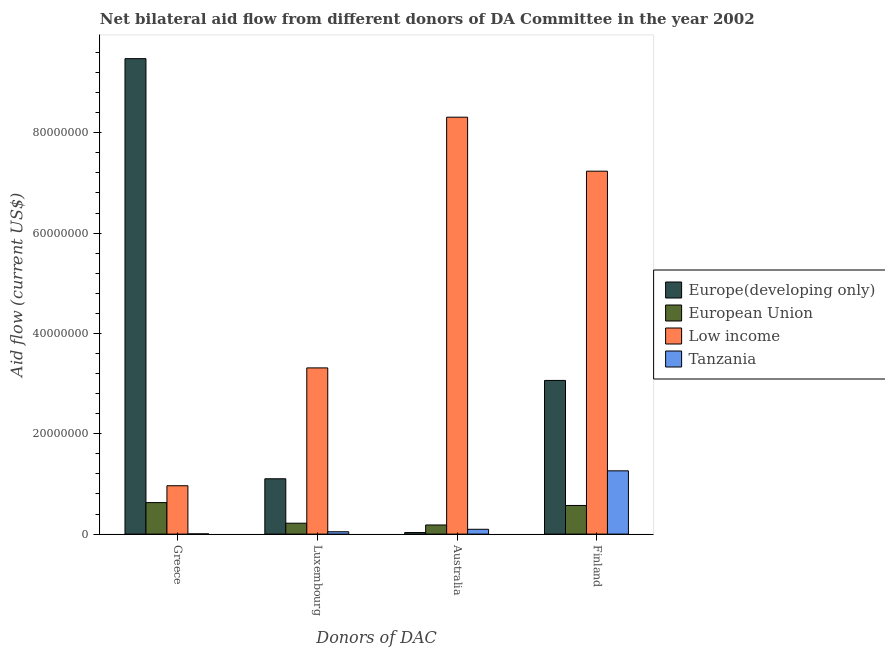How many different coloured bars are there?
Give a very brief answer. 4. Are the number of bars per tick equal to the number of legend labels?
Ensure brevity in your answer.  Yes. How many bars are there on the 1st tick from the left?
Provide a succinct answer. 4. What is the label of the 2nd group of bars from the left?
Keep it short and to the point. Luxembourg. What is the amount of aid given by luxembourg in Europe(developing only)?
Provide a succinct answer. 1.10e+07. Across all countries, what is the maximum amount of aid given by greece?
Provide a succinct answer. 9.48e+07. Across all countries, what is the minimum amount of aid given by luxembourg?
Offer a terse response. 4.70e+05. In which country was the amount of aid given by australia minimum?
Give a very brief answer. Europe(developing only). What is the total amount of aid given by luxembourg in the graph?
Your answer should be compact. 4.68e+07. What is the difference between the amount of aid given by finland in Europe(developing only) and that in European Union?
Ensure brevity in your answer.  2.49e+07. What is the difference between the amount of aid given by greece in Tanzania and the amount of aid given by australia in Low income?
Your answer should be very brief. -8.31e+07. What is the average amount of aid given by luxembourg per country?
Ensure brevity in your answer.  1.17e+07. What is the difference between the amount of aid given by australia and amount of aid given by luxembourg in Low income?
Make the answer very short. 5.00e+07. What is the ratio of the amount of aid given by greece in Tanzania to that in European Union?
Provide a succinct answer. 0.01. Is the amount of aid given by australia in European Union less than that in Low income?
Offer a very short reply. Yes. What is the difference between the highest and the second highest amount of aid given by finland?
Keep it short and to the point. 4.17e+07. What is the difference between the highest and the lowest amount of aid given by australia?
Make the answer very short. 8.28e+07. In how many countries, is the amount of aid given by greece greater than the average amount of aid given by greece taken over all countries?
Your response must be concise. 1. Is the sum of the amount of aid given by luxembourg in European Union and Low income greater than the maximum amount of aid given by australia across all countries?
Provide a short and direct response. No. Is it the case that in every country, the sum of the amount of aid given by australia and amount of aid given by finland is greater than the sum of amount of aid given by luxembourg and amount of aid given by greece?
Offer a very short reply. Yes. What does the 4th bar from the left in Finland represents?
Provide a succinct answer. Tanzania. What does the 4th bar from the right in Finland represents?
Keep it short and to the point. Europe(developing only). Is it the case that in every country, the sum of the amount of aid given by greece and amount of aid given by luxembourg is greater than the amount of aid given by australia?
Give a very brief answer. No. Are the values on the major ticks of Y-axis written in scientific E-notation?
Offer a terse response. No. Does the graph contain any zero values?
Give a very brief answer. No. How are the legend labels stacked?
Offer a terse response. Vertical. What is the title of the graph?
Make the answer very short. Net bilateral aid flow from different donors of DA Committee in the year 2002. Does "Serbia" appear as one of the legend labels in the graph?
Provide a short and direct response. No. What is the label or title of the X-axis?
Ensure brevity in your answer.  Donors of DAC. What is the Aid flow (current US$) in Europe(developing only) in Greece?
Offer a terse response. 9.48e+07. What is the Aid flow (current US$) in European Union in Greece?
Your answer should be compact. 6.28e+06. What is the Aid flow (current US$) in Low income in Greece?
Offer a very short reply. 9.64e+06. What is the Aid flow (current US$) in Tanzania in Greece?
Make the answer very short. 4.00e+04. What is the Aid flow (current US$) of Europe(developing only) in Luxembourg?
Your response must be concise. 1.10e+07. What is the Aid flow (current US$) of European Union in Luxembourg?
Ensure brevity in your answer.  2.17e+06. What is the Aid flow (current US$) of Low income in Luxembourg?
Keep it short and to the point. 3.31e+07. What is the Aid flow (current US$) in Tanzania in Luxembourg?
Keep it short and to the point. 4.70e+05. What is the Aid flow (current US$) of European Union in Australia?
Your answer should be compact. 1.82e+06. What is the Aid flow (current US$) in Low income in Australia?
Your answer should be compact. 8.31e+07. What is the Aid flow (current US$) in Tanzania in Australia?
Your response must be concise. 9.60e+05. What is the Aid flow (current US$) of Europe(developing only) in Finland?
Make the answer very short. 3.06e+07. What is the Aid flow (current US$) in European Union in Finland?
Offer a terse response. 5.71e+06. What is the Aid flow (current US$) in Low income in Finland?
Ensure brevity in your answer.  7.23e+07. What is the Aid flow (current US$) in Tanzania in Finland?
Make the answer very short. 1.26e+07. Across all Donors of DAC, what is the maximum Aid flow (current US$) in Europe(developing only)?
Ensure brevity in your answer.  9.48e+07. Across all Donors of DAC, what is the maximum Aid flow (current US$) of European Union?
Provide a short and direct response. 6.28e+06. Across all Donors of DAC, what is the maximum Aid flow (current US$) in Low income?
Provide a short and direct response. 8.31e+07. Across all Donors of DAC, what is the maximum Aid flow (current US$) of Tanzania?
Keep it short and to the point. 1.26e+07. Across all Donors of DAC, what is the minimum Aid flow (current US$) of Europe(developing only)?
Make the answer very short. 3.10e+05. Across all Donors of DAC, what is the minimum Aid flow (current US$) in European Union?
Provide a short and direct response. 1.82e+06. Across all Donors of DAC, what is the minimum Aid flow (current US$) in Low income?
Keep it short and to the point. 9.64e+06. Across all Donors of DAC, what is the minimum Aid flow (current US$) of Tanzania?
Give a very brief answer. 4.00e+04. What is the total Aid flow (current US$) of Europe(developing only) in the graph?
Provide a succinct answer. 1.37e+08. What is the total Aid flow (current US$) of European Union in the graph?
Make the answer very short. 1.60e+07. What is the total Aid flow (current US$) of Low income in the graph?
Offer a terse response. 1.98e+08. What is the total Aid flow (current US$) of Tanzania in the graph?
Ensure brevity in your answer.  1.41e+07. What is the difference between the Aid flow (current US$) of Europe(developing only) in Greece and that in Luxembourg?
Give a very brief answer. 8.37e+07. What is the difference between the Aid flow (current US$) of European Union in Greece and that in Luxembourg?
Your answer should be very brief. 4.11e+06. What is the difference between the Aid flow (current US$) in Low income in Greece and that in Luxembourg?
Your response must be concise. -2.35e+07. What is the difference between the Aid flow (current US$) of Tanzania in Greece and that in Luxembourg?
Provide a succinct answer. -4.30e+05. What is the difference between the Aid flow (current US$) in Europe(developing only) in Greece and that in Australia?
Keep it short and to the point. 9.45e+07. What is the difference between the Aid flow (current US$) in European Union in Greece and that in Australia?
Keep it short and to the point. 4.46e+06. What is the difference between the Aid flow (current US$) of Low income in Greece and that in Australia?
Offer a terse response. -7.35e+07. What is the difference between the Aid flow (current US$) in Tanzania in Greece and that in Australia?
Provide a succinct answer. -9.20e+05. What is the difference between the Aid flow (current US$) in Europe(developing only) in Greece and that in Finland?
Make the answer very short. 6.41e+07. What is the difference between the Aid flow (current US$) of European Union in Greece and that in Finland?
Give a very brief answer. 5.70e+05. What is the difference between the Aid flow (current US$) in Low income in Greece and that in Finland?
Offer a very short reply. -6.27e+07. What is the difference between the Aid flow (current US$) of Tanzania in Greece and that in Finland?
Your answer should be very brief. -1.26e+07. What is the difference between the Aid flow (current US$) in Europe(developing only) in Luxembourg and that in Australia?
Offer a terse response. 1.07e+07. What is the difference between the Aid flow (current US$) in European Union in Luxembourg and that in Australia?
Make the answer very short. 3.50e+05. What is the difference between the Aid flow (current US$) of Low income in Luxembourg and that in Australia?
Provide a succinct answer. -5.00e+07. What is the difference between the Aid flow (current US$) of Tanzania in Luxembourg and that in Australia?
Offer a terse response. -4.90e+05. What is the difference between the Aid flow (current US$) in Europe(developing only) in Luxembourg and that in Finland?
Keep it short and to the point. -1.96e+07. What is the difference between the Aid flow (current US$) of European Union in Luxembourg and that in Finland?
Make the answer very short. -3.54e+06. What is the difference between the Aid flow (current US$) of Low income in Luxembourg and that in Finland?
Provide a short and direct response. -3.92e+07. What is the difference between the Aid flow (current US$) in Tanzania in Luxembourg and that in Finland?
Offer a very short reply. -1.21e+07. What is the difference between the Aid flow (current US$) in Europe(developing only) in Australia and that in Finland?
Make the answer very short. -3.03e+07. What is the difference between the Aid flow (current US$) of European Union in Australia and that in Finland?
Your answer should be very brief. -3.89e+06. What is the difference between the Aid flow (current US$) in Low income in Australia and that in Finland?
Your answer should be compact. 1.08e+07. What is the difference between the Aid flow (current US$) in Tanzania in Australia and that in Finland?
Offer a terse response. -1.16e+07. What is the difference between the Aid flow (current US$) in Europe(developing only) in Greece and the Aid flow (current US$) in European Union in Luxembourg?
Offer a very short reply. 9.26e+07. What is the difference between the Aid flow (current US$) of Europe(developing only) in Greece and the Aid flow (current US$) of Low income in Luxembourg?
Make the answer very short. 6.16e+07. What is the difference between the Aid flow (current US$) of Europe(developing only) in Greece and the Aid flow (current US$) of Tanzania in Luxembourg?
Keep it short and to the point. 9.43e+07. What is the difference between the Aid flow (current US$) in European Union in Greece and the Aid flow (current US$) in Low income in Luxembourg?
Provide a short and direct response. -2.68e+07. What is the difference between the Aid flow (current US$) of European Union in Greece and the Aid flow (current US$) of Tanzania in Luxembourg?
Ensure brevity in your answer.  5.81e+06. What is the difference between the Aid flow (current US$) of Low income in Greece and the Aid flow (current US$) of Tanzania in Luxembourg?
Provide a short and direct response. 9.17e+06. What is the difference between the Aid flow (current US$) of Europe(developing only) in Greece and the Aid flow (current US$) of European Union in Australia?
Give a very brief answer. 9.30e+07. What is the difference between the Aid flow (current US$) in Europe(developing only) in Greece and the Aid flow (current US$) in Low income in Australia?
Your answer should be very brief. 1.17e+07. What is the difference between the Aid flow (current US$) in Europe(developing only) in Greece and the Aid flow (current US$) in Tanzania in Australia?
Offer a terse response. 9.38e+07. What is the difference between the Aid flow (current US$) of European Union in Greece and the Aid flow (current US$) of Low income in Australia?
Your answer should be very brief. -7.68e+07. What is the difference between the Aid flow (current US$) of European Union in Greece and the Aid flow (current US$) of Tanzania in Australia?
Keep it short and to the point. 5.32e+06. What is the difference between the Aid flow (current US$) in Low income in Greece and the Aid flow (current US$) in Tanzania in Australia?
Your answer should be compact. 8.68e+06. What is the difference between the Aid flow (current US$) in Europe(developing only) in Greece and the Aid flow (current US$) in European Union in Finland?
Make the answer very short. 8.91e+07. What is the difference between the Aid flow (current US$) in Europe(developing only) in Greece and the Aid flow (current US$) in Low income in Finland?
Your answer should be very brief. 2.24e+07. What is the difference between the Aid flow (current US$) in Europe(developing only) in Greece and the Aid flow (current US$) in Tanzania in Finland?
Provide a succinct answer. 8.22e+07. What is the difference between the Aid flow (current US$) in European Union in Greece and the Aid flow (current US$) in Low income in Finland?
Offer a terse response. -6.61e+07. What is the difference between the Aid flow (current US$) of European Union in Greece and the Aid flow (current US$) of Tanzania in Finland?
Provide a succinct answer. -6.33e+06. What is the difference between the Aid flow (current US$) in Low income in Greece and the Aid flow (current US$) in Tanzania in Finland?
Your response must be concise. -2.97e+06. What is the difference between the Aid flow (current US$) of Europe(developing only) in Luxembourg and the Aid flow (current US$) of European Union in Australia?
Provide a succinct answer. 9.21e+06. What is the difference between the Aid flow (current US$) in Europe(developing only) in Luxembourg and the Aid flow (current US$) in Low income in Australia?
Offer a terse response. -7.21e+07. What is the difference between the Aid flow (current US$) of Europe(developing only) in Luxembourg and the Aid flow (current US$) of Tanzania in Australia?
Offer a very short reply. 1.01e+07. What is the difference between the Aid flow (current US$) of European Union in Luxembourg and the Aid flow (current US$) of Low income in Australia?
Offer a terse response. -8.09e+07. What is the difference between the Aid flow (current US$) in European Union in Luxembourg and the Aid flow (current US$) in Tanzania in Australia?
Your response must be concise. 1.21e+06. What is the difference between the Aid flow (current US$) of Low income in Luxembourg and the Aid flow (current US$) of Tanzania in Australia?
Keep it short and to the point. 3.22e+07. What is the difference between the Aid flow (current US$) of Europe(developing only) in Luxembourg and the Aid flow (current US$) of European Union in Finland?
Your answer should be compact. 5.32e+06. What is the difference between the Aid flow (current US$) in Europe(developing only) in Luxembourg and the Aid flow (current US$) in Low income in Finland?
Give a very brief answer. -6.13e+07. What is the difference between the Aid flow (current US$) in Europe(developing only) in Luxembourg and the Aid flow (current US$) in Tanzania in Finland?
Offer a very short reply. -1.58e+06. What is the difference between the Aid flow (current US$) of European Union in Luxembourg and the Aid flow (current US$) of Low income in Finland?
Provide a short and direct response. -7.02e+07. What is the difference between the Aid flow (current US$) of European Union in Luxembourg and the Aid flow (current US$) of Tanzania in Finland?
Give a very brief answer. -1.04e+07. What is the difference between the Aid flow (current US$) in Low income in Luxembourg and the Aid flow (current US$) in Tanzania in Finland?
Provide a short and direct response. 2.05e+07. What is the difference between the Aid flow (current US$) in Europe(developing only) in Australia and the Aid flow (current US$) in European Union in Finland?
Your answer should be very brief. -5.40e+06. What is the difference between the Aid flow (current US$) in Europe(developing only) in Australia and the Aid flow (current US$) in Low income in Finland?
Give a very brief answer. -7.20e+07. What is the difference between the Aid flow (current US$) in Europe(developing only) in Australia and the Aid flow (current US$) in Tanzania in Finland?
Your response must be concise. -1.23e+07. What is the difference between the Aid flow (current US$) of European Union in Australia and the Aid flow (current US$) of Low income in Finland?
Make the answer very short. -7.05e+07. What is the difference between the Aid flow (current US$) of European Union in Australia and the Aid flow (current US$) of Tanzania in Finland?
Ensure brevity in your answer.  -1.08e+07. What is the difference between the Aid flow (current US$) of Low income in Australia and the Aid flow (current US$) of Tanzania in Finland?
Make the answer very short. 7.05e+07. What is the average Aid flow (current US$) in Europe(developing only) per Donors of DAC?
Offer a terse response. 3.42e+07. What is the average Aid flow (current US$) of European Union per Donors of DAC?
Provide a short and direct response. 4.00e+06. What is the average Aid flow (current US$) in Low income per Donors of DAC?
Make the answer very short. 4.96e+07. What is the average Aid flow (current US$) in Tanzania per Donors of DAC?
Your answer should be very brief. 3.52e+06. What is the difference between the Aid flow (current US$) of Europe(developing only) and Aid flow (current US$) of European Union in Greece?
Your answer should be very brief. 8.85e+07. What is the difference between the Aid flow (current US$) in Europe(developing only) and Aid flow (current US$) in Low income in Greece?
Provide a short and direct response. 8.51e+07. What is the difference between the Aid flow (current US$) of Europe(developing only) and Aid flow (current US$) of Tanzania in Greece?
Keep it short and to the point. 9.47e+07. What is the difference between the Aid flow (current US$) of European Union and Aid flow (current US$) of Low income in Greece?
Make the answer very short. -3.36e+06. What is the difference between the Aid flow (current US$) of European Union and Aid flow (current US$) of Tanzania in Greece?
Provide a succinct answer. 6.24e+06. What is the difference between the Aid flow (current US$) in Low income and Aid flow (current US$) in Tanzania in Greece?
Offer a very short reply. 9.60e+06. What is the difference between the Aid flow (current US$) in Europe(developing only) and Aid flow (current US$) in European Union in Luxembourg?
Your answer should be very brief. 8.86e+06. What is the difference between the Aid flow (current US$) of Europe(developing only) and Aid flow (current US$) of Low income in Luxembourg?
Give a very brief answer. -2.21e+07. What is the difference between the Aid flow (current US$) of Europe(developing only) and Aid flow (current US$) of Tanzania in Luxembourg?
Give a very brief answer. 1.06e+07. What is the difference between the Aid flow (current US$) of European Union and Aid flow (current US$) of Low income in Luxembourg?
Give a very brief answer. -3.10e+07. What is the difference between the Aid flow (current US$) of European Union and Aid flow (current US$) of Tanzania in Luxembourg?
Give a very brief answer. 1.70e+06. What is the difference between the Aid flow (current US$) in Low income and Aid flow (current US$) in Tanzania in Luxembourg?
Offer a very short reply. 3.27e+07. What is the difference between the Aid flow (current US$) in Europe(developing only) and Aid flow (current US$) in European Union in Australia?
Your answer should be very brief. -1.51e+06. What is the difference between the Aid flow (current US$) in Europe(developing only) and Aid flow (current US$) in Low income in Australia?
Make the answer very short. -8.28e+07. What is the difference between the Aid flow (current US$) of Europe(developing only) and Aid flow (current US$) of Tanzania in Australia?
Give a very brief answer. -6.50e+05. What is the difference between the Aid flow (current US$) in European Union and Aid flow (current US$) in Low income in Australia?
Keep it short and to the point. -8.13e+07. What is the difference between the Aid flow (current US$) in European Union and Aid flow (current US$) in Tanzania in Australia?
Give a very brief answer. 8.60e+05. What is the difference between the Aid flow (current US$) in Low income and Aid flow (current US$) in Tanzania in Australia?
Your answer should be compact. 8.21e+07. What is the difference between the Aid flow (current US$) in Europe(developing only) and Aid flow (current US$) in European Union in Finland?
Provide a short and direct response. 2.49e+07. What is the difference between the Aid flow (current US$) of Europe(developing only) and Aid flow (current US$) of Low income in Finland?
Make the answer very short. -4.17e+07. What is the difference between the Aid flow (current US$) in Europe(developing only) and Aid flow (current US$) in Tanzania in Finland?
Provide a short and direct response. 1.80e+07. What is the difference between the Aid flow (current US$) in European Union and Aid flow (current US$) in Low income in Finland?
Make the answer very short. -6.66e+07. What is the difference between the Aid flow (current US$) in European Union and Aid flow (current US$) in Tanzania in Finland?
Offer a very short reply. -6.90e+06. What is the difference between the Aid flow (current US$) in Low income and Aid flow (current US$) in Tanzania in Finland?
Provide a short and direct response. 5.97e+07. What is the ratio of the Aid flow (current US$) of Europe(developing only) in Greece to that in Luxembourg?
Make the answer very short. 8.59. What is the ratio of the Aid flow (current US$) in European Union in Greece to that in Luxembourg?
Offer a terse response. 2.89. What is the ratio of the Aid flow (current US$) of Low income in Greece to that in Luxembourg?
Keep it short and to the point. 0.29. What is the ratio of the Aid flow (current US$) in Tanzania in Greece to that in Luxembourg?
Offer a very short reply. 0.09. What is the ratio of the Aid flow (current US$) in Europe(developing only) in Greece to that in Australia?
Give a very brief answer. 305.71. What is the ratio of the Aid flow (current US$) of European Union in Greece to that in Australia?
Your response must be concise. 3.45. What is the ratio of the Aid flow (current US$) of Low income in Greece to that in Australia?
Provide a succinct answer. 0.12. What is the ratio of the Aid flow (current US$) of Tanzania in Greece to that in Australia?
Keep it short and to the point. 0.04. What is the ratio of the Aid flow (current US$) in Europe(developing only) in Greece to that in Finland?
Your answer should be very brief. 3.09. What is the ratio of the Aid flow (current US$) in European Union in Greece to that in Finland?
Your answer should be very brief. 1.1. What is the ratio of the Aid flow (current US$) of Low income in Greece to that in Finland?
Keep it short and to the point. 0.13. What is the ratio of the Aid flow (current US$) of Tanzania in Greece to that in Finland?
Offer a very short reply. 0. What is the ratio of the Aid flow (current US$) of Europe(developing only) in Luxembourg to that in Australia?
Provide a short and direct response. 35.58. What is the ratio of the Aid flow (current US$) of European Union in Luxembourg to that in Australia?
Give a very brief answer. 1.19. What is the ratio of the Aid flow (current US$) in Low income in Luxembourg to that in Australia?
Keep it short and to the point. 0.4. What is the ratio of the Aid flow (current US$) in Tanzania in Luxembourg to that in Australia?
Your response must be concise. 0.49. What is the ratio of the Aid flow (current US$) in Europe(developing only) in Luxembourg to that in Finland?
Your response must be concise. 0.36. What is the ratio of the Aid flow (current US$) of European Union in Luxembourg to that in Finland?
Make the answer very short. 0.38. What is the ratio of the Aid flow (current US$) in Low income in Luxembourg to that in Finland?
Your answer should be compact. 0.46. What is the ratio of the Aid flow (current US$) of Tanzania in Luxembourg to that in Finland?
Your answer should be compact. 0.04. What is the ratio of the Aid flow (current US$) of Europe(developing only) in Australia to that in Finland?
Give a very brief answer. 0.01. What is the ratio of the Aid flow (current US$) in European Union in Australia to that in Finland?
Offer a very short reply. 0.32. What is the ratio of the Aid flow (current US$) of Low income in Australia to that in Finland?
Your answer should be very brief. 1.15. What is the ratio of the Aid flow (current US$) in Tanzania in Australia to that in Finland?
Your answer should be very brief. 0.08. What is the difference between the highest and the second highest Aid flow (current US$) in Europe(developing only)?
Make the answer very short. 6.41e+07. What is the difference between the highest and the second highest Aid flow (current US$) in European Union?
Give a very brief answer. 5.70e+05. What is the difference between the highest and the second highest Aid flow (current US$) of Low income?
Your answer should be very brief. 1.08e+07. What is the difference between the highest and the second highest Aid flow (current US$) in Tanzania?
Offer a very short reply. 1.16e+07. What is the difference between the highest and the lowest Aid flow (current US$) in Europe(developing only)?
Offer a terse response. 9.45e+07. What is the difference between the highest and the lowest Aid flow (current US$) of European Union?
Give a very brief answer. 4.46e+06. What is the difference between the highest and the lowest Aid flow (current US$) of Low income?
Ensure brevity in your answer.  7.35e+07. What is the difference between the highest and the lowest Aid flow (current US$) in Tanzania?
Make the answer very short. 1.26e+07. 